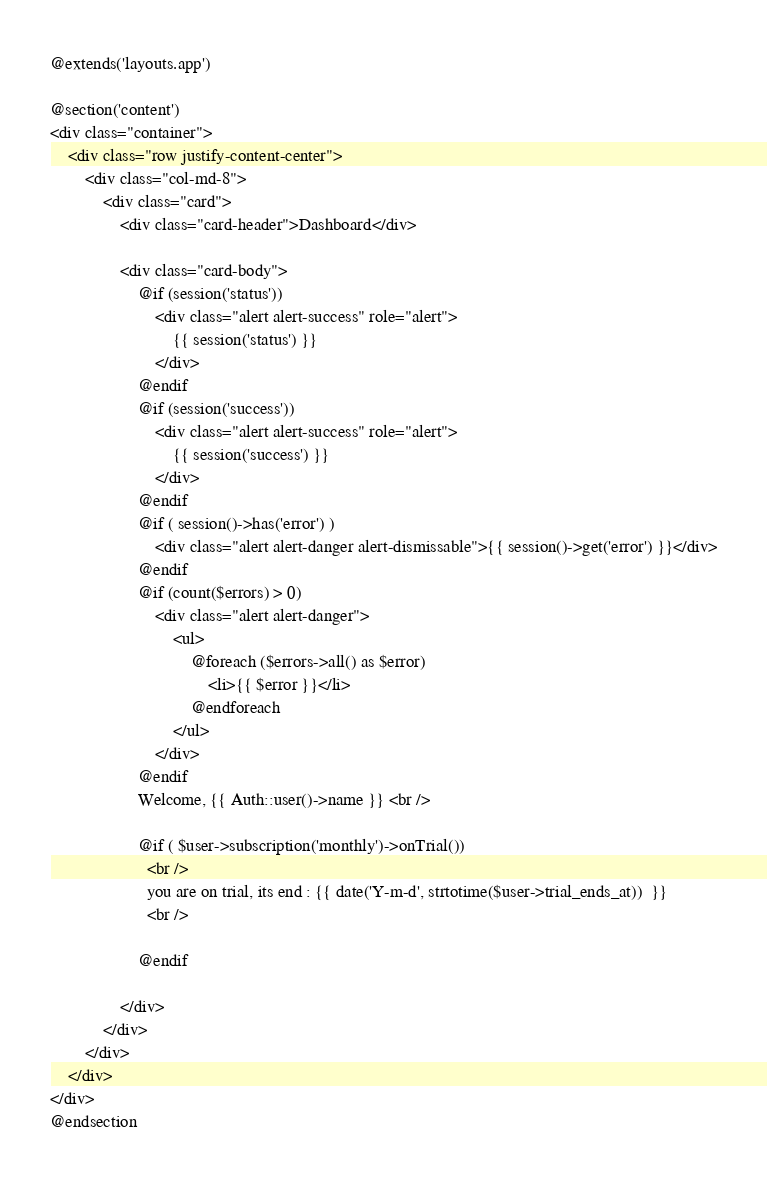<code> <loc_0><loc_0><loc_500><loc_500><_PHP_>@extends('layouts.app')

@section('content')
<div class="container">
    <div class="row justify-content-center">
        <div class="col-md-8">
            <div class="card">
                <div class="card-header">Dashboard</div>

                <div class="card-body">
                    @if (session('status'))
                        <div class="alert alert-success" role="alert">
                            {{ session('status') }}
                        </div>
                    @endif
                    @if (session('success'))
                        <div class="alert alert-success" role="alert">
                            {{ session('success') }}
                        </div>
                    @endif
                    @if ( session()->has('error') )
                        <div class="alert alert-danger alert-dismissable">{{ session()->get('error') }}</div>
                    @endif
                    @if (count($errors) > 0)
                        <div class="alert alert-danger">
                            <ul>
                                @foreach ($errors->all() as $error)
                                    <li>{{ $error }}</li>
                                @endforeach
                            </ul>
                        </div>
                    @endif
                    Welcome, {{ Auth::user()->name }} <br />

                    @if ( $user->subscription('monthly')->onTrial())
                      <br />
                      you are on trial, its end : {{ date('Y-m-d', strtotime($user->trial_ends_at))  }}
                      <br />

                    @endif

                </div>
            </div>
        </div>
    </div>
</div>
@endsection
</code> 